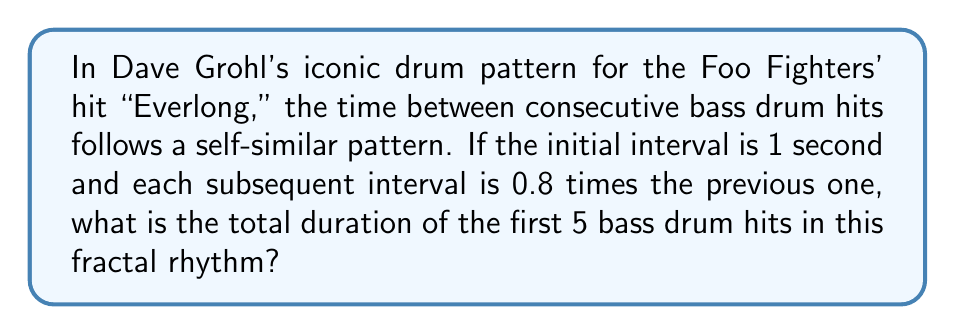Could you help me with this problem? Let's approach this step-by-step:

1) First, we need to calculate the time intervals between each hit:
   - Initial interval: 1 second
   - Second interval: $1 * 0.8 = 0.8$ seconds
   - Third interval: $0.8 * 0.8 = 0.64$ seconds
   - Fourth interval: $0.64 * 0.8 = 0.512$ seconds

2) Now, let's set up a geometric series to represent these intervals:
   $$S = 1 + 0.8 + 0.64 + 0.512$$

3) This is a geometric series with:
   - First term $a = 1$
   - Common ratio $r = 0.8$
   - Number of terms $n = 4$

4) The sum of a geometric series is given by the formula:
   $$S = \frac{a(1-r^n)}{1-r}$$

5) Plugging in our values:
   $$S = \frac{1(1-0.8^4)}{1-0.8} = \frac{1(1-0.4096)}{0.2} = \frac{0.5904}{0.2}$$

6) Calculating this:
   $$S = 2.952$$

7) However, this sum only gives us the time up to the start of the 5th hit. To include the 5th hit itself, we need to add one more time unit (the initial interval):
   $$\text{Total duration} = 2.952 + 1 = 3.952$$

Thus, the total duration of the first 5 bass drum hits is 3.952 seconds.
Answer: 3.952 seconds 